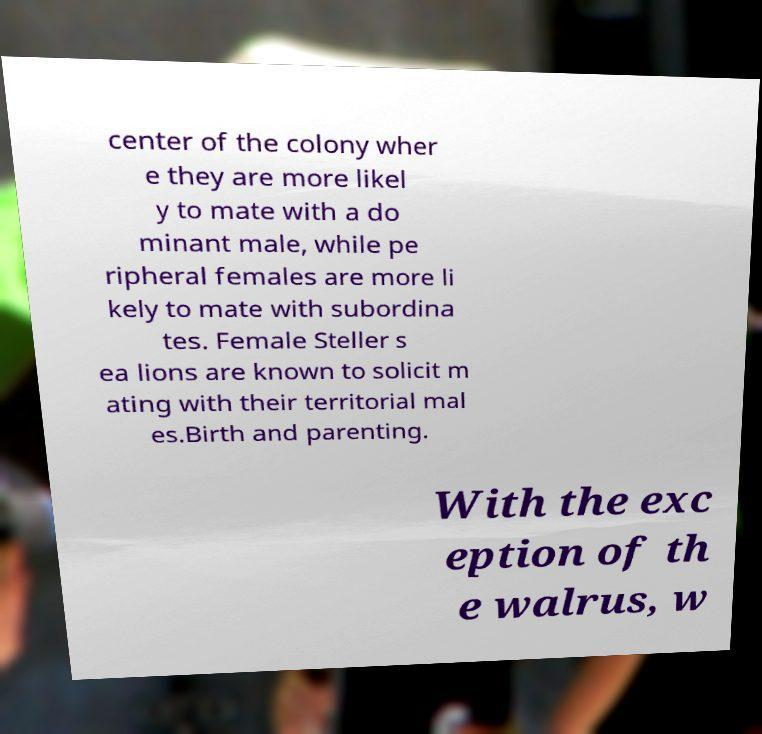Please identify and transcribe the text found in this image. center of the colony wher e they are more likel y to mate with a do minant male, while pe ripheral females are more li kely to mate with subordina tes. Female Steller s ea lions are known to solicit m ating with their territorial mal es.Birth and parenting. With the exc eption of th e walrus, w 